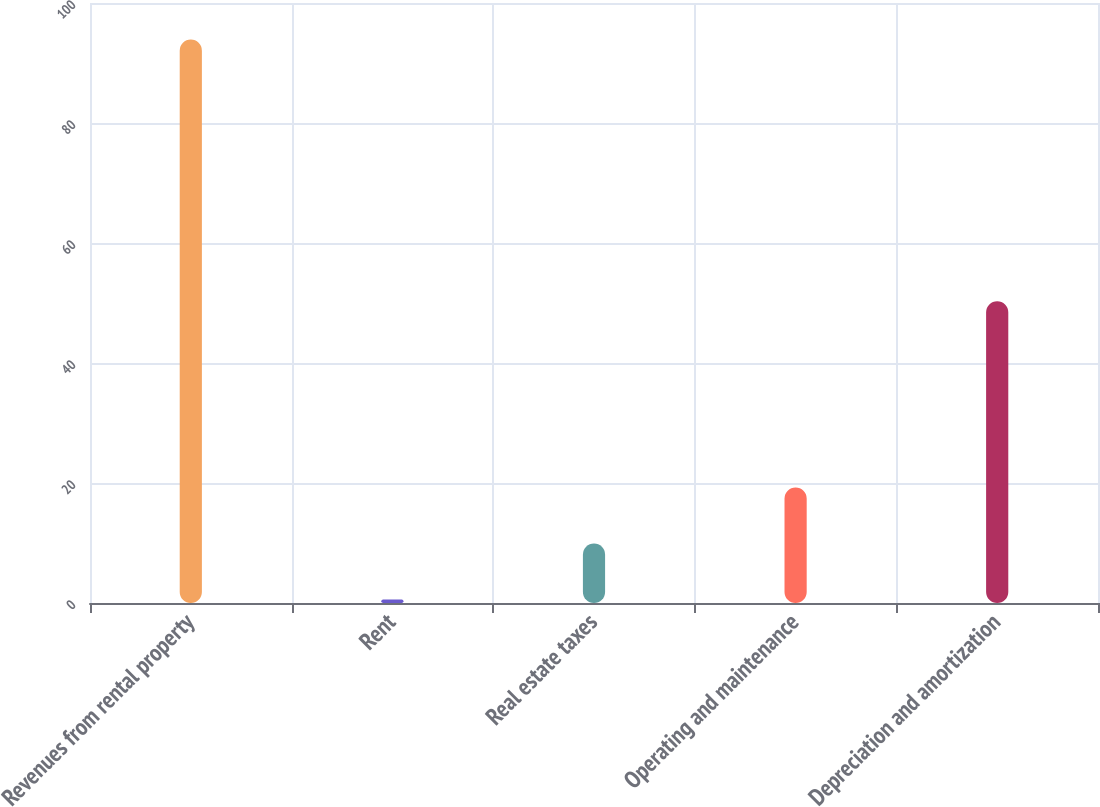Convert chart to OTSL. <chart><loc_0><loc_0><loc_500><loc_500><bar_chart><fcel>Revenues from rental property<fcel>Rent<fcel>Real estate taxes<fcel>Operating and maintenance<fcel>Depreciation and amortization<nl><fcel>93.9<fcel>0.6<fcel>9.93<fcel>19.26<fcel>50.3<nl></chart> 